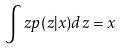Convert formula to latex. <formula><loc_0><loc_0><loc_500><loc_500>\int z p ( z | x ) d z = x</formula> 